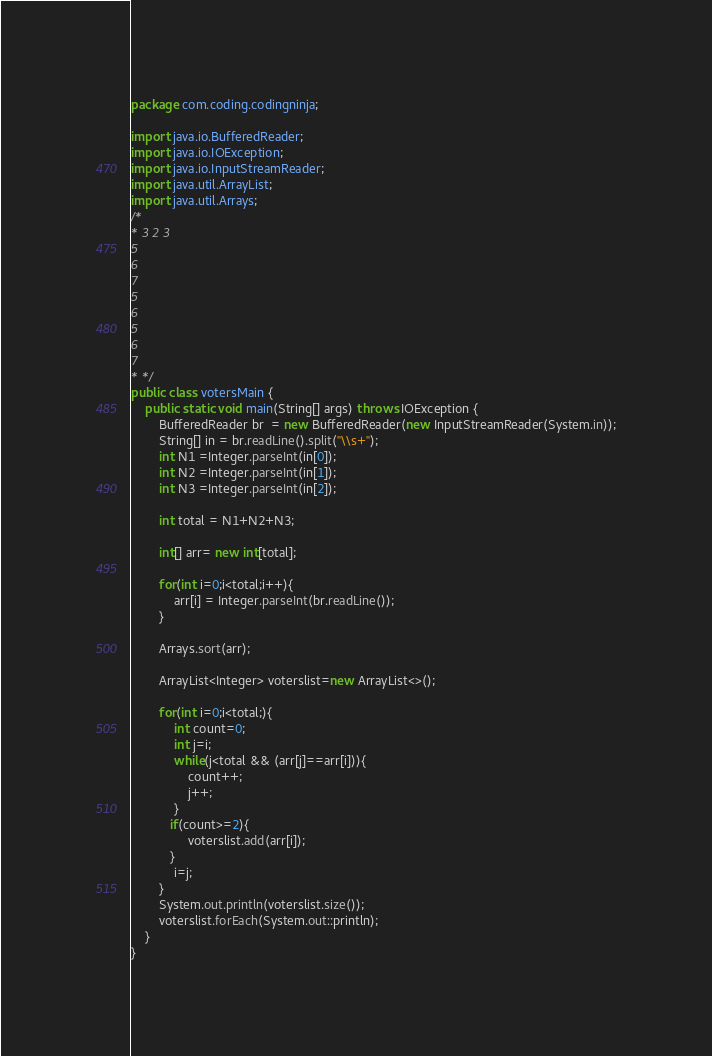<code> <loc_0><loc_0><loc_500><loc_500><_Java_>package com.coding.codingninja;

import java.io.BufferedReader;
import java.io.IOException;
import java.io.InputStreamReader;
import java.util.ArrayList;
import java.util.Arrays;
/*
* 3 2 3
5
6
7
5
6
5
6
7
* */
public class votersMain {
    public static void main(String[] args) throws IOException {
        BufferedReader br  = new BufferedReader(new InputStreamReader(System.in));
        String[] in = br.readLine().split("\\s+");
        int N1 =Integer.parseInt(in[0]);
        int N2 =Integer.parseInt(in[1]);
        int N3 =Integer.parseInt(in[2]);

        int total = N1+N2+N3;

        int[] arr= new int[total];

        for(int i=0;i<total;i++){
            arr[i] = Integer.parseInt(br.readLine());
        }

        Arrays.sort(arr);

        ArrayList<Integer> voterslist=new ArrayList<>();

        for(int i=0;i<total;){
            int count=0;
            int j=i;
            while(j<total && (arr[j]==arr[i])){
                count++;
                j++;
            }
           if(count>=2){
                voterslist.add(arr[i]);
           }
            i=j;
        }
        System.out.println(voterslist.size());
        voterslist.forEach(System.out::println);
    }
}
</code> 